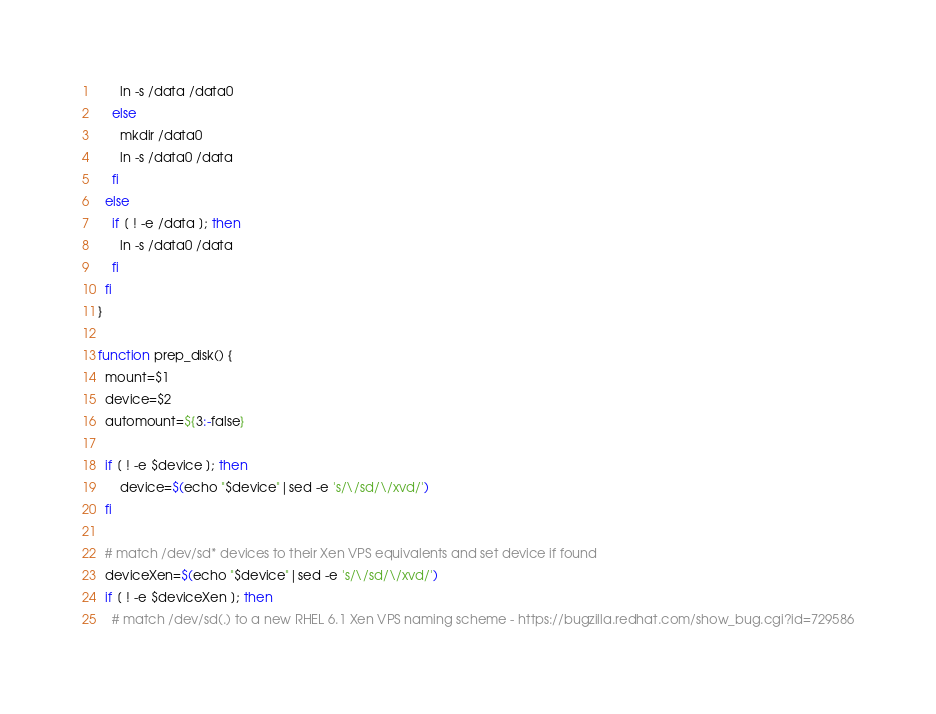Convert code to text. <code><loc_0><loc_0><loc_500><loc_500><_Bash_>      ln -s /data /data0
    else
      mkdir /data0
      ln -s /data0 /data
    fi
  else
    if [ ! -e /data ]; then
      ln -s /data0 /data
    fi
  fi
}

function prep_disk() {
  mount=$1
  device=$2
  automount=${3:-false}

  if [ ! -e $device ]; then
      device=$(echo "$device"|sed -e 's/\/sd/\/xvd/')
  fi

  # match /dev/sd* devices to their Xen VPS equivalents and set device if found
  deviceXen=$(echo "$device"|sed -e 's/\/sd/\/xvd/')
  if [ ! -e $deviceXen ]; then
    # match /dev/sd(.) to a new RHEL 6.1 Xen VPS naming scheme - https://bugzilla.redhat.com/show_bug.cgi?id=729586</code> 